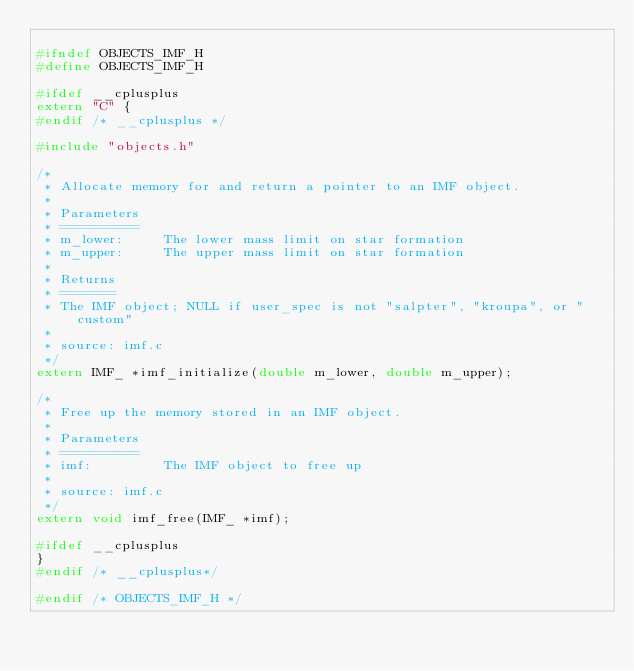<code> <loc_0><loc_0><loc_500><loc_500><_C_>
#ifndef OBJECTS_IMF_H 
#define OBJECTS_IMF_H 

#ifdef __cplusplus 
extern "C" {
#endif /* __cplusplus */ 

#include "objects.h" 

/* 
 * Allocate memory for and return a pointer to an IMF object. 
 * 
 * Parameters 
 * ========== 
 * m_lower: 	The lower mass limit on star formation 
 * m_upper: 	The upper mass limit on star formation 
 * 
 * Returns 
 * ======= 
 * The IMF object; NULL if user_spec is not "salpter", "kroupa", or "custom" 
 * 
 * source: imf.c 
 */ 
extern IMF_ *imf_initialize(double m_lower, double m_upper); 

/* 
 * Free up the memory stored in an IMF object. 
 * 
 * Parameters 
 * ========== 
 * imf: 		The IMF object to free up 
 * 
 * source: imf.c 
 */ 
extern void imf_free(IMF_ *imf); 

#ifdef __cplusplus 
} 
#endif /* __cplusplus*/ 

#endif /* OBJECTS_IMF_H */ 

</code> 